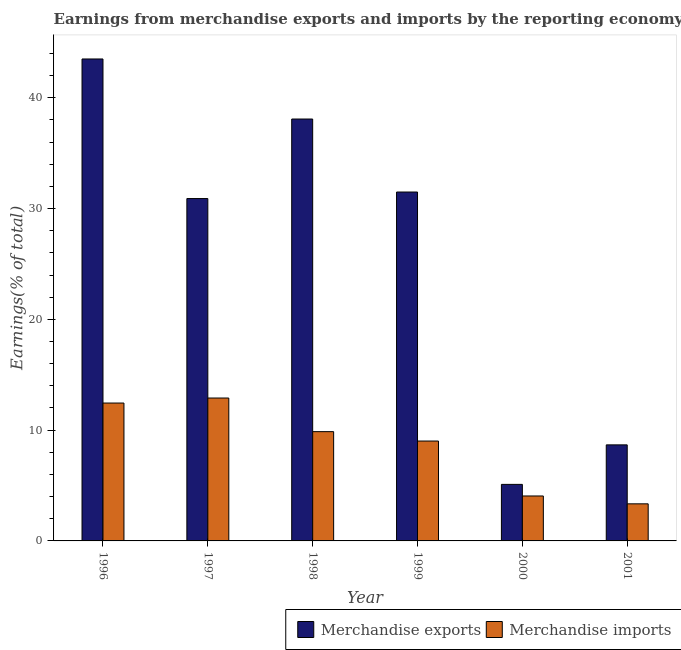Are the number of bars per tick equal to the number of legend labels?
Keep it short and to the point. Yes. What is the earnings from merchandise imports in 1999?
Make the answer very short. 9.02. Across all years, what is the maximum earnings from merchandise exports?
Provide a short and direct response. 43.5. Across all years, what is the minimum earnings from merchandise exports?
Keep it short and to the point. 5.1. What is the total earnings from merchandise imports in the graph?
Ensure brevity in your answer.  51.62. What is the difference between the earnings from merchandise imports in 2000 and that in 2001?
Ensure brevity in your answer.  0.71. What is the difference between the earnings from merchandise exports in 2000 and the earnings from merchandise imports in 1998?
Ensure brevity in your answer.  -32.98. What is the average earnings from merchandise imports per year?
Ensure brevity in your answer.  8.6. What is the ratio of the earnings from merchandise imports in 2000 to that in 2001?
Your response must be concise. 1.21. Is the difference between the earnings from merchandise exports in 1997 and 1999 greater than the difference between the earnings from merchandise imports in 1997 and 1999?
Give a very brief answer. No. What is the difference between the highest and the second highest earnings from merchandise imports?
Your answer should be very brief. 0.45. What is the difference between the highest and the lowest earnings from merchandise imports?
Ensure brevity in your answer.  9.55. In how many years, is the earnings from merchandise imports greater than the average earnings from merchandise imports taken over all years?
Give a very brief answer. 4. What does the 1st bar from the left in 2001 represents?
Give a very brief answer. Merchandise exports. How many bars are there?
Provide a short and direct response. 12. Are the values on the major ticks of Y-axis written in scientific E-notation?
Give a very brief answer. No. Does the graph contain grids?
Offer a terse response. No. Where does the legend appear in the graph?
Ensure brevity in your answer.  Bottom right. How are the legend labels stacked?
Give a very brief answer. Horizontal. What is the title of the graph?
Provide a succinct answer. Earnings from merchandise exports and imports by the reporting economy(residual) of Aruba. What is the label or title of the Y-axis?
Ensure brevity in your answer.  Earnings(% of total). What is the Earnings(% of total) of Merchandise exports in 1996?
Offer a terse response. 43.5. What is the Earnings(% of total) of Merchandise imports in 1996?
Ensure brevity in your answer.  12.44. What is the Earnings(% of total) of Merchandise exports in 1997?
Your answer should be compact. 30.9. What is the Earnings(% of total) in Merchandise imports in 1997?
Your answer should be very brief. 12.9. What is the Earnings(% of total) in Merchandise exports in 1998?
Provide a succinct answer. 38.08. What is the Earnings(% of total) of Merchandise imports in 1998?
Ensure brevity in your answer.  9.86. What is the Earnings(% of total) in Merchandise exports in 1999?
Offer a terse response. 31.49. What is the Earnings(% of total) in Merchandise imports in 1999?
Provide a succinct answer. 9.02. What is the Earnings(% of total) in Merchandise exports in 2000?
Provide a short and direct response. 5.1. What is the Earnings(% of total) in Merchandise imports in 2000?
Provide a short and direct response. 4.06. What is the Earnings(% of total) of Merchandise exports in 2001?
Your response must be concise. 8.67. What is the Earnings(% of total) of Merchandise imports in 2001?
Give a very brief answer. 3.35. Across all years, what is the maximum Earnings(% of total) in Merchandise exports?
Your response must be concise. 43.5. Across all years, what is the maximum Earnings(% of total) in Merchandise imports?
Your answer should be very brief. 12.9. Across all years, what is the minimum Earnings(% of total) in Merchandise exports?
Offer a very short reply. 5.1. Across all years, what is the minimum Earnings(% of total) in Merchandise imports?
Your answer should be very brief. 3.35. What is the total Earnings(% of total) of Merchandise exports in the graph?
Provide a succinct answer. 157.74. What is the total Earnings(% of total) of Merchandise imports in the graph?
Your answer should be compact. 51.62. What is the difference between the Earnings(% of total) in Merchandise exports in 1996 and that in 1997?
Offer a terse response. 12.6. What is the difference between the Earnings(% of total) in Merchandise imports in 1996 and that in 1997?
Provide a succinct answer. -0.45. What is the difference between the Earnings(% of total) of Merchandise exports in 1996 and that in 1998?
Keep it short and to the point. 5.42. What is the difference between the Earnings(% of total) of Merchandise imports in 1996 and that in 1998?
Offer a terse response. 2.58. What is the difference between the Earnings(% of total) in Merchandise exports in 1996 and that in 1999?
Your response must be concise. 12.01. What is the difference between the Earnings(% of total) in Merchandise imports in 1996 and that in 1999?
Give a very brief answer. 3.43. What is the difference between the Earnings(% of total) in Merchandise exports in 1996 and that in 2000?
Your response must be concise. 38.39. What is the difference between the Earnings(% of total) in Merchandise imports in 1996 and that in 2000?
Your response must be concise. 8.39. What is the difference between the Earnings(% of total) in Merchandise exports in 1996 and that in 2001?
Ensure brevity in your answer.  34.83. What is the difference between the Earnings(% of total) of Merchandise imports in 1996 and that in 2001?
Ensure brevity in your answer.  9.1. What is the difference between the Earnings(% of total) of Merchandise exports in 1997 and that in 1998?
Make the answer very short. -7.18. What is the difference between the Earnings(% of total) in Merchandise imports in 1997 and that in 1998?
Provide a succinct answer. 3.03. What is the difference between the Earnings(% of total) in Merchandise exports in 1997 and that in 1999?
Offer a terse response. -0.59. What is the difference between the Earnings(% of total) of Merchandise imports in 1997 and that in 1999?
Your response must be concise. 3.88. What is the difference between the Earnings(% of total) of Merchandise exports in 1997 and that in 2000?
Your response must be concise. 25.8. What is the difference between the Earnings(% of total) of Merchandise imports in 1997 and that in 2000?
Ensure brevity in your answer.  8.84. What is the difference between the Earnings(% of total) in Merchandise exports in 1997 and that in 2001?
Give a very brief answer. 22.23. What is the difference between the Earnings(% of total) of Merchandise imports in 1997 and that in 2001?
Offer a terse response. 9.55. What is the difference between the Earnings(% of total) of Merchandise exports in 1998 and that in 1999?
Offer a very short reply. 6.59. What is the difference between the Earnings(% of total) of Merchandise imports in 1998 and that in 1999?
Your response must be concise. 0.85. What is the difference between the Earnings(% of total) of Merchandise exports in 1998 and that in 2000?
Provide a succinct answer. 32.98. What is the difference between the Earnings(% of total) in Merchandise imports in 1998 and that in 2000?
Your answer should be compact. 5.81. What is the difference between the Earnings(% of total) of Merchandise exports in 1998 and that in 2001?
Your answer should be compact. 29.41. What is the difference between the Earnings(% of total) in Merchandise imports in 1998 and that in 2001?
Your answer should be very brief. 6.52. What is the difference between the Earnings(% of total) in Merchandise exports in 1999 and that in 2000?
Keep it short and to the point. 26.39. What is the difference between the Earnings(% of total) of Merchandise imports in 1999 and that in 2000?
Your answer should be very brief. 4.96. What is the difference between the Earnings(% of total) in Merchandise exports in 1999 and that in 2001?
Your answer should be very brief. 22.82. What is the difference between the Earnings(% of total) of Merchandise imports in 1999 and that in 2001?
Offer a very short reply. 5.67. What is the difference between the Earnings(% of total) of Merchandise exports in 2000 and that in 2001?
Provide a succinct answer. -3.57. What is the difference between the Earnings(% of total) in Merchandise imports in 2000 and that in 2001?
Ensure brevity in your answer.  0.71. What is the difference between the Earnings(% of total) in Merchandise exports in 1996 and the Earnings(% of total) in Merchandise imports in 1997?
Keep it short and to the point. 30.6. What is the difference between the Earnings(% of total) in Merchandise exports in 1996 and the Earnings(% of total) in Merchandise imports in 1998?
Provide a short and direct response. 33.63. What is the difference between the Earnings(% of total) of Merchandise exports in 1996 and the Earnings(% of total) of Merchandise imports in 1999?
Offer a very short reply. 34.48. What is the difference between the Earnings(% of total) of Merchandise exports in 1996 and the Earnings(% of total) of Merchandise imports in 2000?
Your answer should be very brief. 39.44. What is the difference between the Earnings(% of total) of Merchandise exports in 1996 and the Earnings(% of total) of Merchandise imports in 2001?
Your answer should be very brief. 40.15. What is the difference between the Earnings(% of total) in Merchandise exports in 1997 and the Earnings(% of total) in Merchandise imports in 1998?
Keep it short and to the point. 21.04. What is the difference between the Earnings(% of total) of Merchandise exports in 1997 and the Earnings(% of total) of Merchandise imports in 1999?
Give a very brief answer. 21.89. What is the difference between the Earnings(% of total) in Merchandise exports in 1997 and the Earnings(% of total) in Merchandise imports in 2000?
Offer a terse response. 26.84. What is the difference between the Earnings(% of total) in Merchandise exports in 1997 and the Earnings(% of total) in Merchandise imports in 2001?
Offer a terse response. 27.55. What is the difference between the Earnings(% of total) of Merchandise exports in 1998 and the Earnings(% of total) of Merchandise imports in 1999?
Provide a succinct answer. 29.06. What is the difference between the Earnings(% of total) in Merchandise exports in 1998 and the Earnings(% of total) in Merchandise imports in 2000?
Make the answer very short. 34.02. What is the difference between the Earnings(% of total) of Merchandise exports in 1998 and the Earnings(% of total) of Merchandise imports in 2001?
Offer a very short reply. 34.73. What is the difference between the Earnings(% of total) in Merchandise exports in 1999 and the Earnings(% of total) in Merchandise imports in 2000?
Make the answer very short. 27.43. What is the difference between the Earnings(% of total) in Merchandise exports in 1999 and the Earnings(% of total) in Merchandise imports in 2001?
Provide a short and direct response. 28.14. What is the difference between the Earnings(% of total) in Merchandise exports in 2000 and the Earnings(% of total) in Merchandise imports in 2001?
Your answer should be compact. 1.76. What is the average Earnings(% of total) in Merchandise exports per year?
Offer a very short reply. 26.29. What is the average Earnings(% of total) in Merchandise imports per year?
Make the answer very short. 8.6. In the year 1996, what is the difference between the Earnings(% of total) of Merchandise exports and Earnings(% of total) of Merchandise imports?
Provide a short and direct response. 31.05. In the year 1997, what is the difference between the Earnings(% of total) of Merchandise exports and Earnings(% of total) of Merchandise imports?
Your answer should be compact. 18. In the year 1998, what is the difference between the Earnings(% of total) in Merchandise exports and Earnings(% of total) in Merchandise imports?
Provide a succinct answer. 28.22. In the year 1999, what is the difference between the Earnings(% of total) in Merchandise exports and Earnings(% of total) in Merchandise imports?
Offer a very short reply. 22.47. In the year 2000, what is the difference between the Earnings(% of total) in Merchandise exports and Earnings(% of total) in Merchandise imports?
Ensure brevity in your answer.  1.05. In the year 2001, what is the difference between the Earnings(% of total) in Merchandise exports and Earnings(% of total) in Merchandise imports?
Provide a succinct answer. 5.32. What is the ratio of the Earnings(% of total) in Merchandise exports in 1996 to that in 1997?
Make the answer very short. 1.41. What is the ratio of the Earnings(% of total) in Merchandise imports in 1996 to that in 1997?
Your answer should be very brief. 0.96. What is the ratio of the Earnings(% of total) in Merchandise exports in 1996 to that in 1998?
Your answer should be very brief. 1.14. What is the ratio of the Earnings(% of total) in Merchandise imports in 1996 to that in 1998?
Ensure brevity in your answer.  1.26. What is the ratio of the Earnings(% of total) in Merchandise exports in 1996 to that in 1999?
Your response must be concise. 1.38. What is the ratio of the Earnings(% of total) in Merchandise imports in 1996 to that in 1999?
Ensure brevity in your answer.  1.38. What is the ratio of the Earnings(% of total) in Merchandise exports in 1996 to that in 2000?
Give a very brief answer. 8.52. What is the ratio of the Earnings(% of total) in Merchandise imports in 1996 to that in 2000?
Your answer should be very brief. 3.07. What is the ratio of the Earnings(% of total) in Merchandise exports in 1996 to that in 2001?
Offer a terse response. 5.02. What is the ratio of the Earnings(% of total) of Merchandise imports in 1996 to that in 2001?
Keep it short and to the point. 3.72. What is the ratio of the Earnings(% of total) of Merchandise exports in 1997 to that in 1998?
Give a very brief answer. 0.81. What is the ratio of the Earnings(% of total) in Merchandise imports in 1997 to that in 1998?
Provide a succinct answer. 1.31. What is the ratio of the Earnings(% of total) of Merchandise exports in 1997 to that in 1999?
Keep it short and to the point. 0.98. What is the ratio of the Earnings(% of total) of Merchandise imports in 1997 to that in 1999?
Provide a short and direct response. 1.43. What is the ratio of the Earnings(% of total) in Merchandise exports in 1997 to that in 2000?
Give a very brief answer. 6.06. What is the ratio of the Earnings(% of total) in Merchandise imports in 1997 to that in 2000?
Offer a terse response. 3.18. What is the ratio of the Earnings(% of total) of Merchandise exports in 1997 to that in 2001?
Keep it short and to the point. 3.56. What is the ratio of the Earnings(% of total) in Merchandise imports in 1997 to that in 2001?
Keep it short and to the point. 3.85. What is the ratio of the Earnings(% of total) in Merchandise exports in 1998 to that in 1999?
Provide a succinct answer. 1.21. What is the ratio of the Earnings(% of total) of Merchandise imports in 1998 to that in 1999?
Offer a terse response. 1.09. What is the ratio of the Earnings(% of total) of Merchandise exports in 1998 to that in 2000?
Ensure brevity in your answer.  7.46. What is the ratio of the Earnings(% of total) of Merchandise imports in 1998 to that in 2000?
Ensure brevity in your answer.  2.43. What is the ratio of the Earnings(% of total) of Merchandise exports in 1998 to that in 2001?
Keep it short and to the point. 4.39. What is the ratio of the Earnings(% of total) in Merchandise imports in 1998 to that in 2001?
Offer a terse response. 2.95. What is the ratio of the Earnings(% of total) of Merchandise exports in 1999 to that in 2000?
Give a very brief answer. 6.17. What is the ratio of the Earnings(% of total) of Merchandise imports in 1999 to that in 2000?
Make the answer very short. 2.22. What is the ratio of the Earnings(% of total) of Merchandise exports in 1999 to that in 2001?
Your answer should be compact. 3.63. What is the ratio of the Earnings(% of total) in Merchandise imports in 1999 to that in 2001?
Your response must be concise. 2.69. What is the ratio of the Earnings(% of total) of Merchandise exports in 2000 to that in 2001?
Provide a short and direct response. 0.59. What is the ratio of the Earnings(% of total) of Merchandise imports in 2000 to that in 2001?
Make the answer very short. 1.21. What is the difference between the highest and the second highest Earnings(% of total) in Merchandise exports?
Provide a succinct answer. 5.42. What is the difference between the highest and the second highest Earnings(% of total) of Merchandise imports?
Your answer should be compact. 0.45. What is the difference between the highest and the lowest Earnings(% of total) in Merchandise exports?
Provide a short and direct response. 38.39. What is the difference between the highest and the lowest Earnings(% of total) of Merchandise imports?
Ensure brevity in your answer.  9.55. 